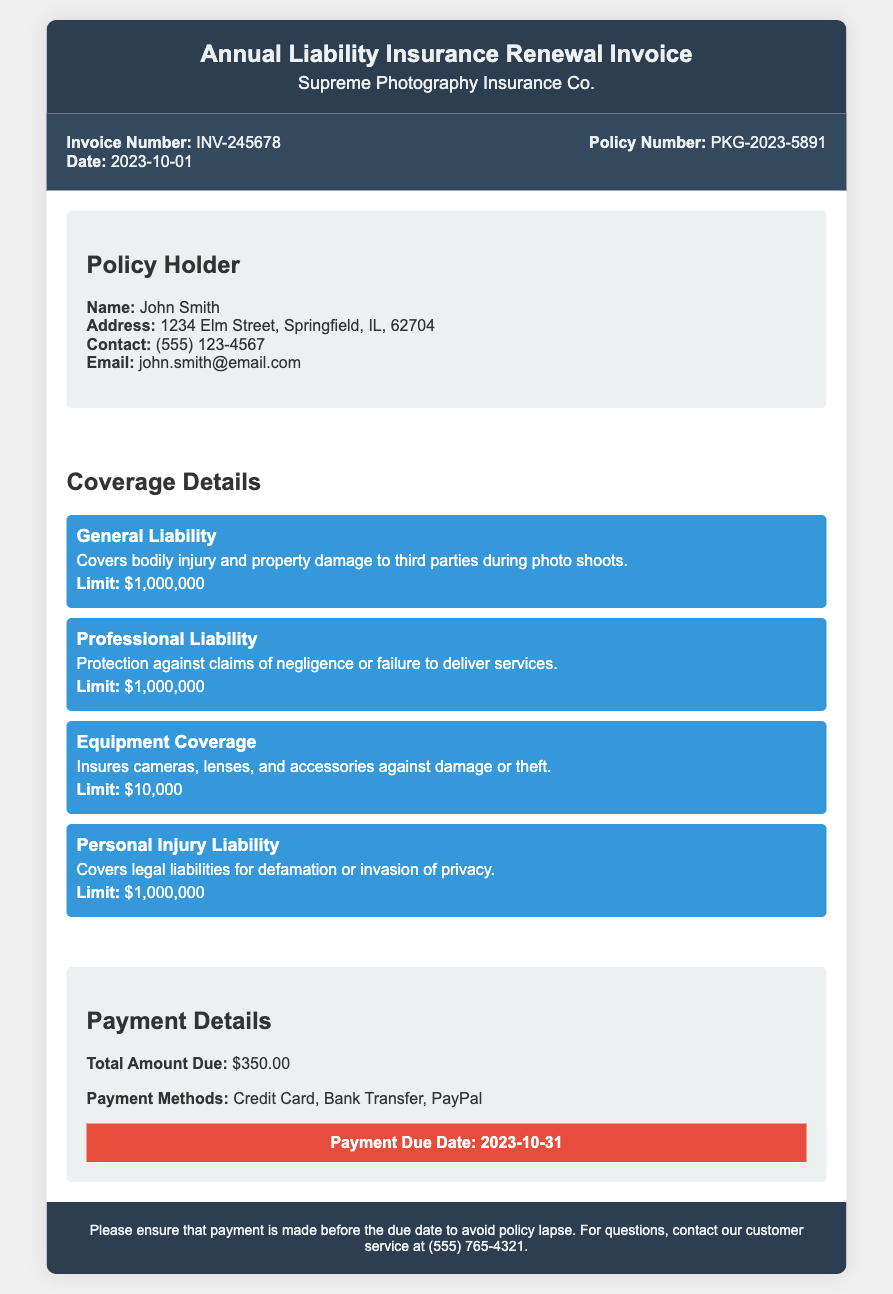What is the invoice number? The invoice number is a unique identifier for this transaction, found in the document.
Answer: INV-245678 Who is the policy holder? The policy holder is the individual covered by the insurance policy, as stated in the document.
Answer: John Smith What is the total amount due? The total amount due is the full payment required for the insurance renewal, specified in the document.
Answer: $350.00 What is the coverage limit for General Liability? The coverage limit represents the maximum amount payable for a specific type of coverage, as shown in the document.
Answer: $1,000,000 What is the payment due date? The payment due date indicates when the payment must be made to keep the insurance active, detailed in the document.
Answer: 2023-10-31 What types of coverage are included in the policy? The document lists different types of coverage provided under the insurance policy.
Answer: General Liability, Professional Liability, Equipment Coverage, Personal Injury Liability What methods of payment are accepted? Accepted payment methods provide options for settling the invoice, as outlined in the payment details section of the document.
Answer: Credit Card, Bank Transfer, PayPal What address is listed for the policy holder? The address identifies where the policy holder resides, given in the document.
Answer: 1234 Elm Street, Springfield, IL, 62704 